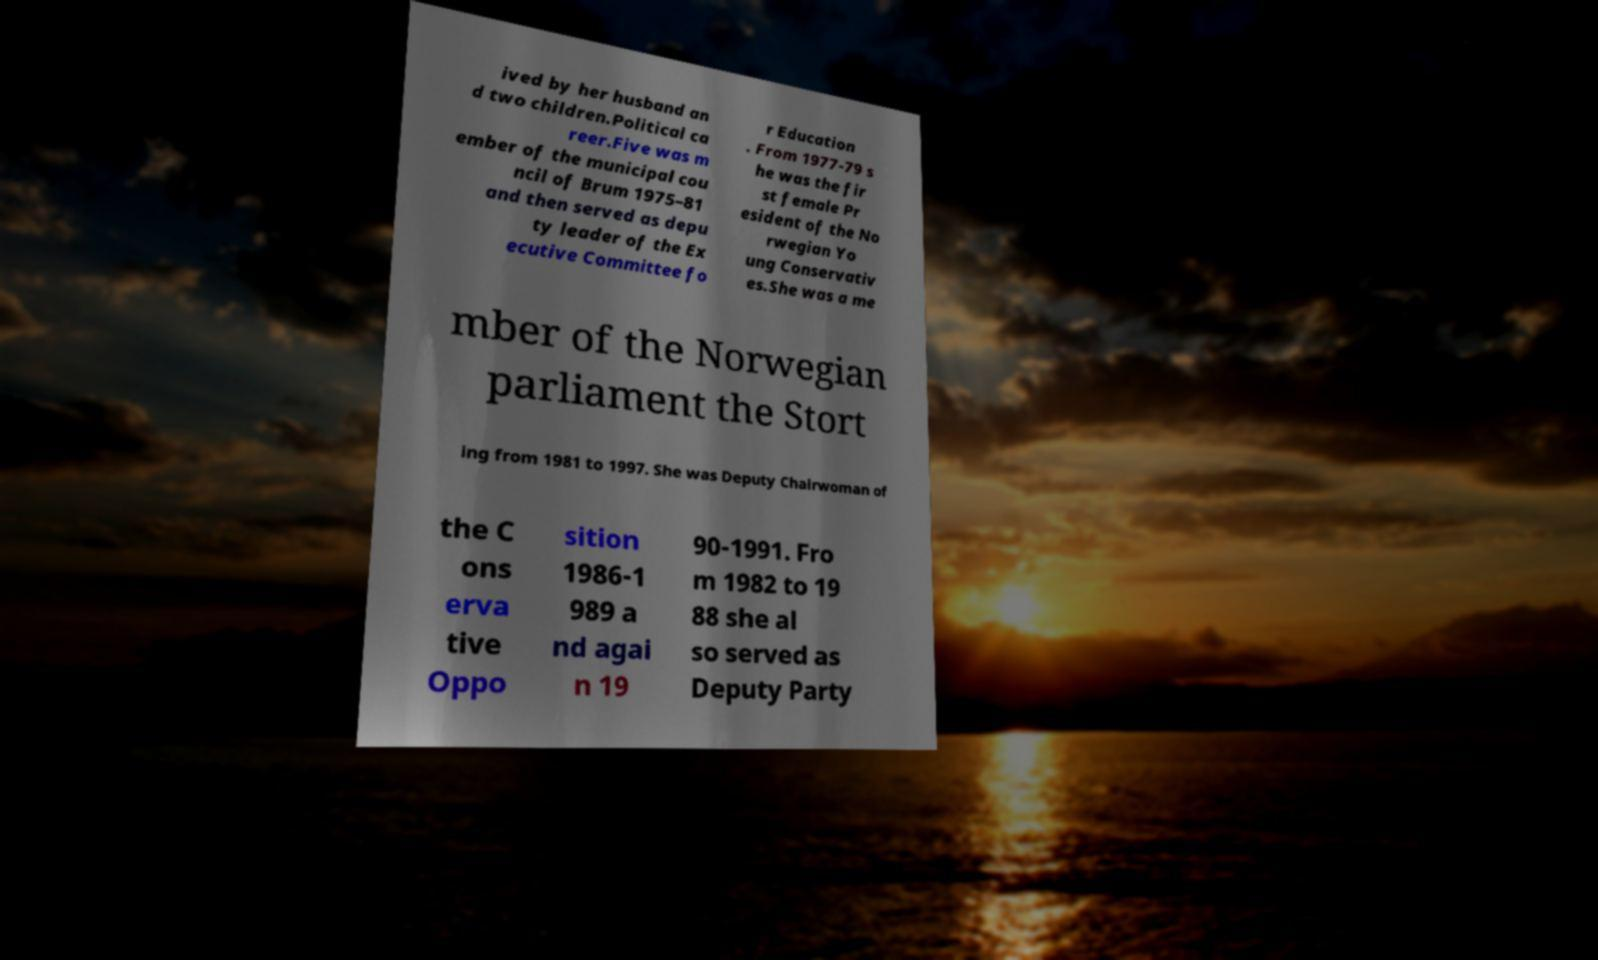Could you assist in decoding the text presented in this image and type it out clearly? ived by her husband an d two children.Political ca reer.Five was m ember of the municipal cou ncil of Brum 1975–81 and then served as depu ty leader of the Ex ecutive Committee fo r Education . From 1977-79 s he was the fir st female Pr esident of the No rwegian Yo ung Conservativ es.She was a me mber of the Norwegian parliament the Stort ing from 1981 to 1997. She was Deputy Chairwoman of the C ons erva tive Oppo sition 1986-1 989 a nd agai n 19 90-1991. Fro m 1982 to 19 88 she al so served as Deputy Party 